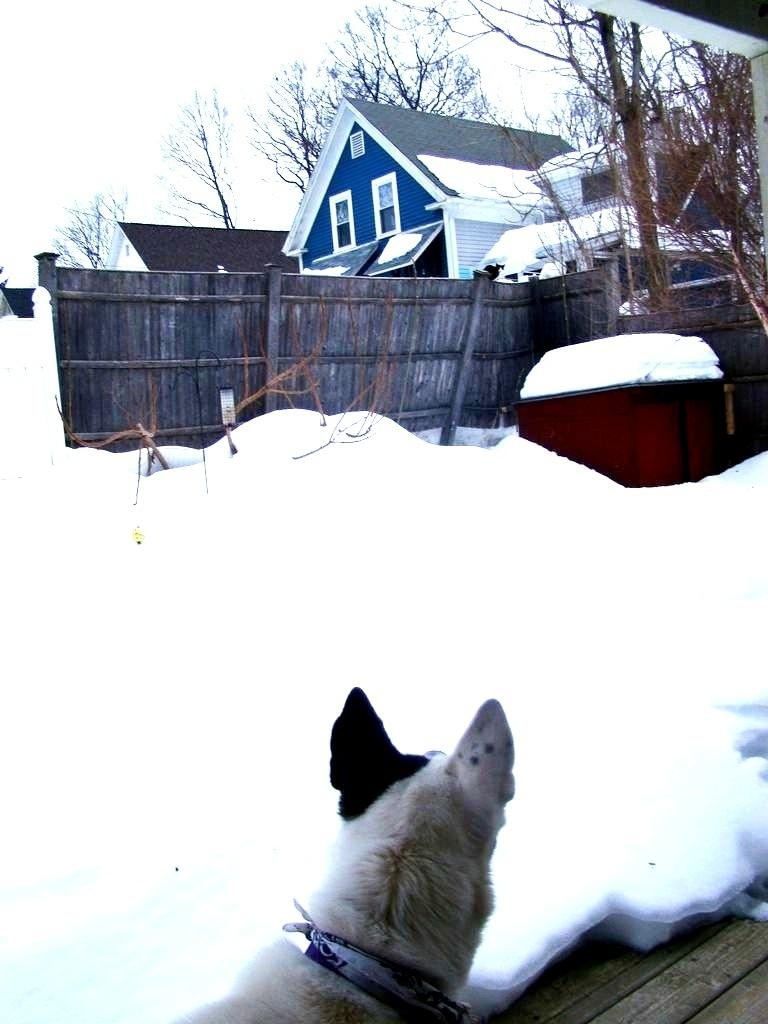What type of structures can be seen in the image? There are buildings in the image. What other objects are present in the image? There are fences and trees in the image. How is the ground depicted in the image? The ground is covered with snow in the image. What can be seen in the background of the image? The sky is visible in the background of the image. What type of face can be seen on the tree in the image? There is no face present on the tree in the image. 